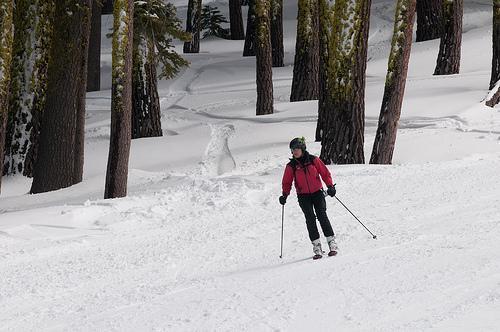How many people are visible?
Give a very brief answer. 1. 